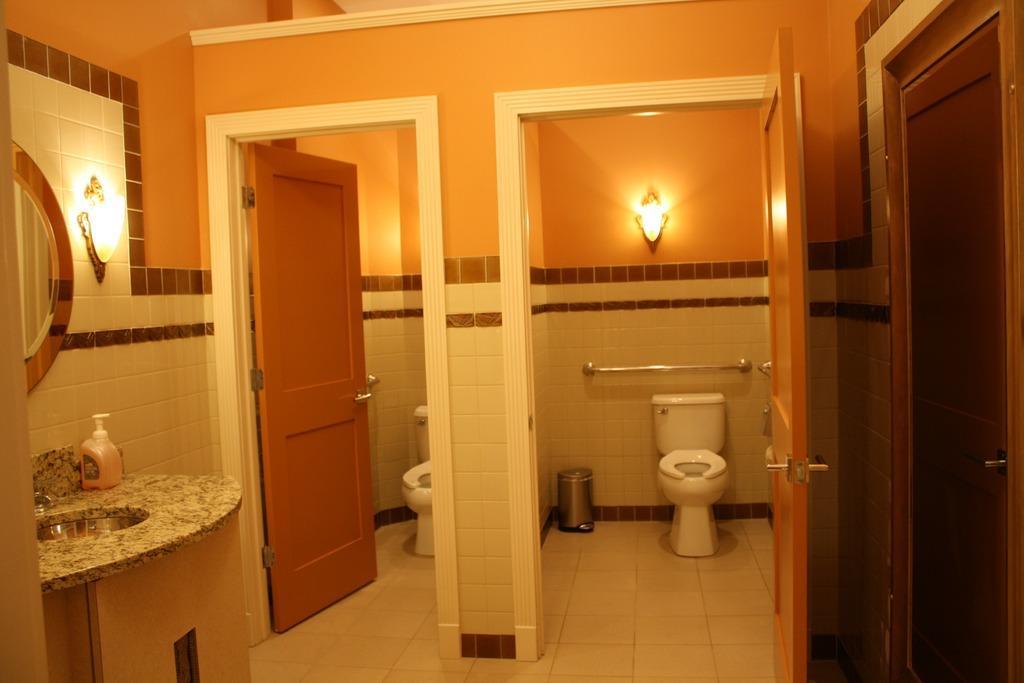Describe this image in one or two sentences. This picture might be taken inside the room. In this image, on the right side, we can see a door which is closed. In the middle of the image, we can see a door which is opened, in the room, we can see a toilet, dustbin and a light. On the left side, we can also see a door which is opened, on the left side, we can also see a toilet. On the left side, we can see a wash basin, mirror and a light. At the bottom there are some tiles. 